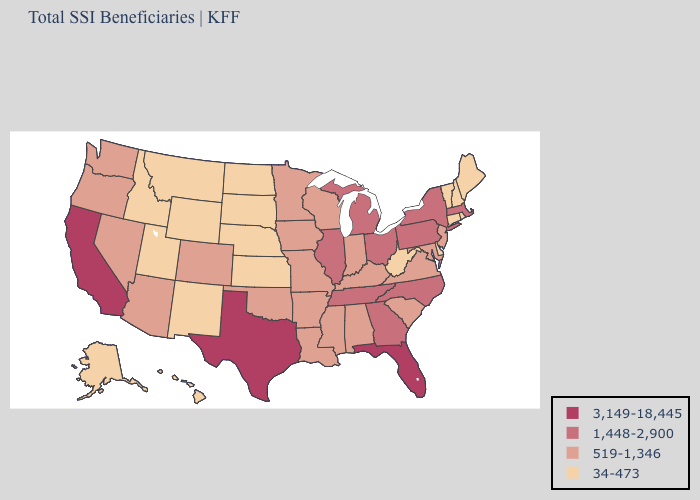Does the map have missing data?
Keep it brief. No. What is the lowest value in states that border Missouri?
Quick response, please. 34-473. What is the highest value in the USA?
Write a very short answer. 3,149-18,445. What is the value of Kansas?
Answer briefly. 34-473. What is the lowest value in the MidWest?
Be succinct. 34-473. What is the value of New York?
Quick response, please. 1,448-2,900. Name the states that have a value in the range 34-473?
Be succinct. Alaska, Connecticut, Delaware, Hawaii, Idaho, Kansas, Maine, Montana, Nebraska, New Hampshire, New Mexico, North Dakota, Rhode Island, South Dakota, Utah, Vermont, West Virginia, Wyoming. Name the states that have a value in the range 34-473?
Give a very brief answer. Alaska, Connecticut, Delaware, Hawaii, Idaho, Kansas, Maine, Montana, Nebraska, New Hampshire, New Mexico, North Dakota, Rhode Island, South Dakota, Utah, Vermont, West Virginia, Wyoming. What is the value of Michigan?
Quick response, please. 1,448-2,900. Which states hav the highest value in the Northeast?
Concise answer only. Massachusetts, New York, Pennsylvania. Among the states that border Kansas , does Oklahoma have the lowest value?
Give a very brief answer. No. What is the value of Maryland?
Answer briefly. 519-1,346. What is the highest value in states that border Utah?
Keep it brief. 519-1,346. What is the value of Wisconsin?
Short answer required. 519-1,346. 